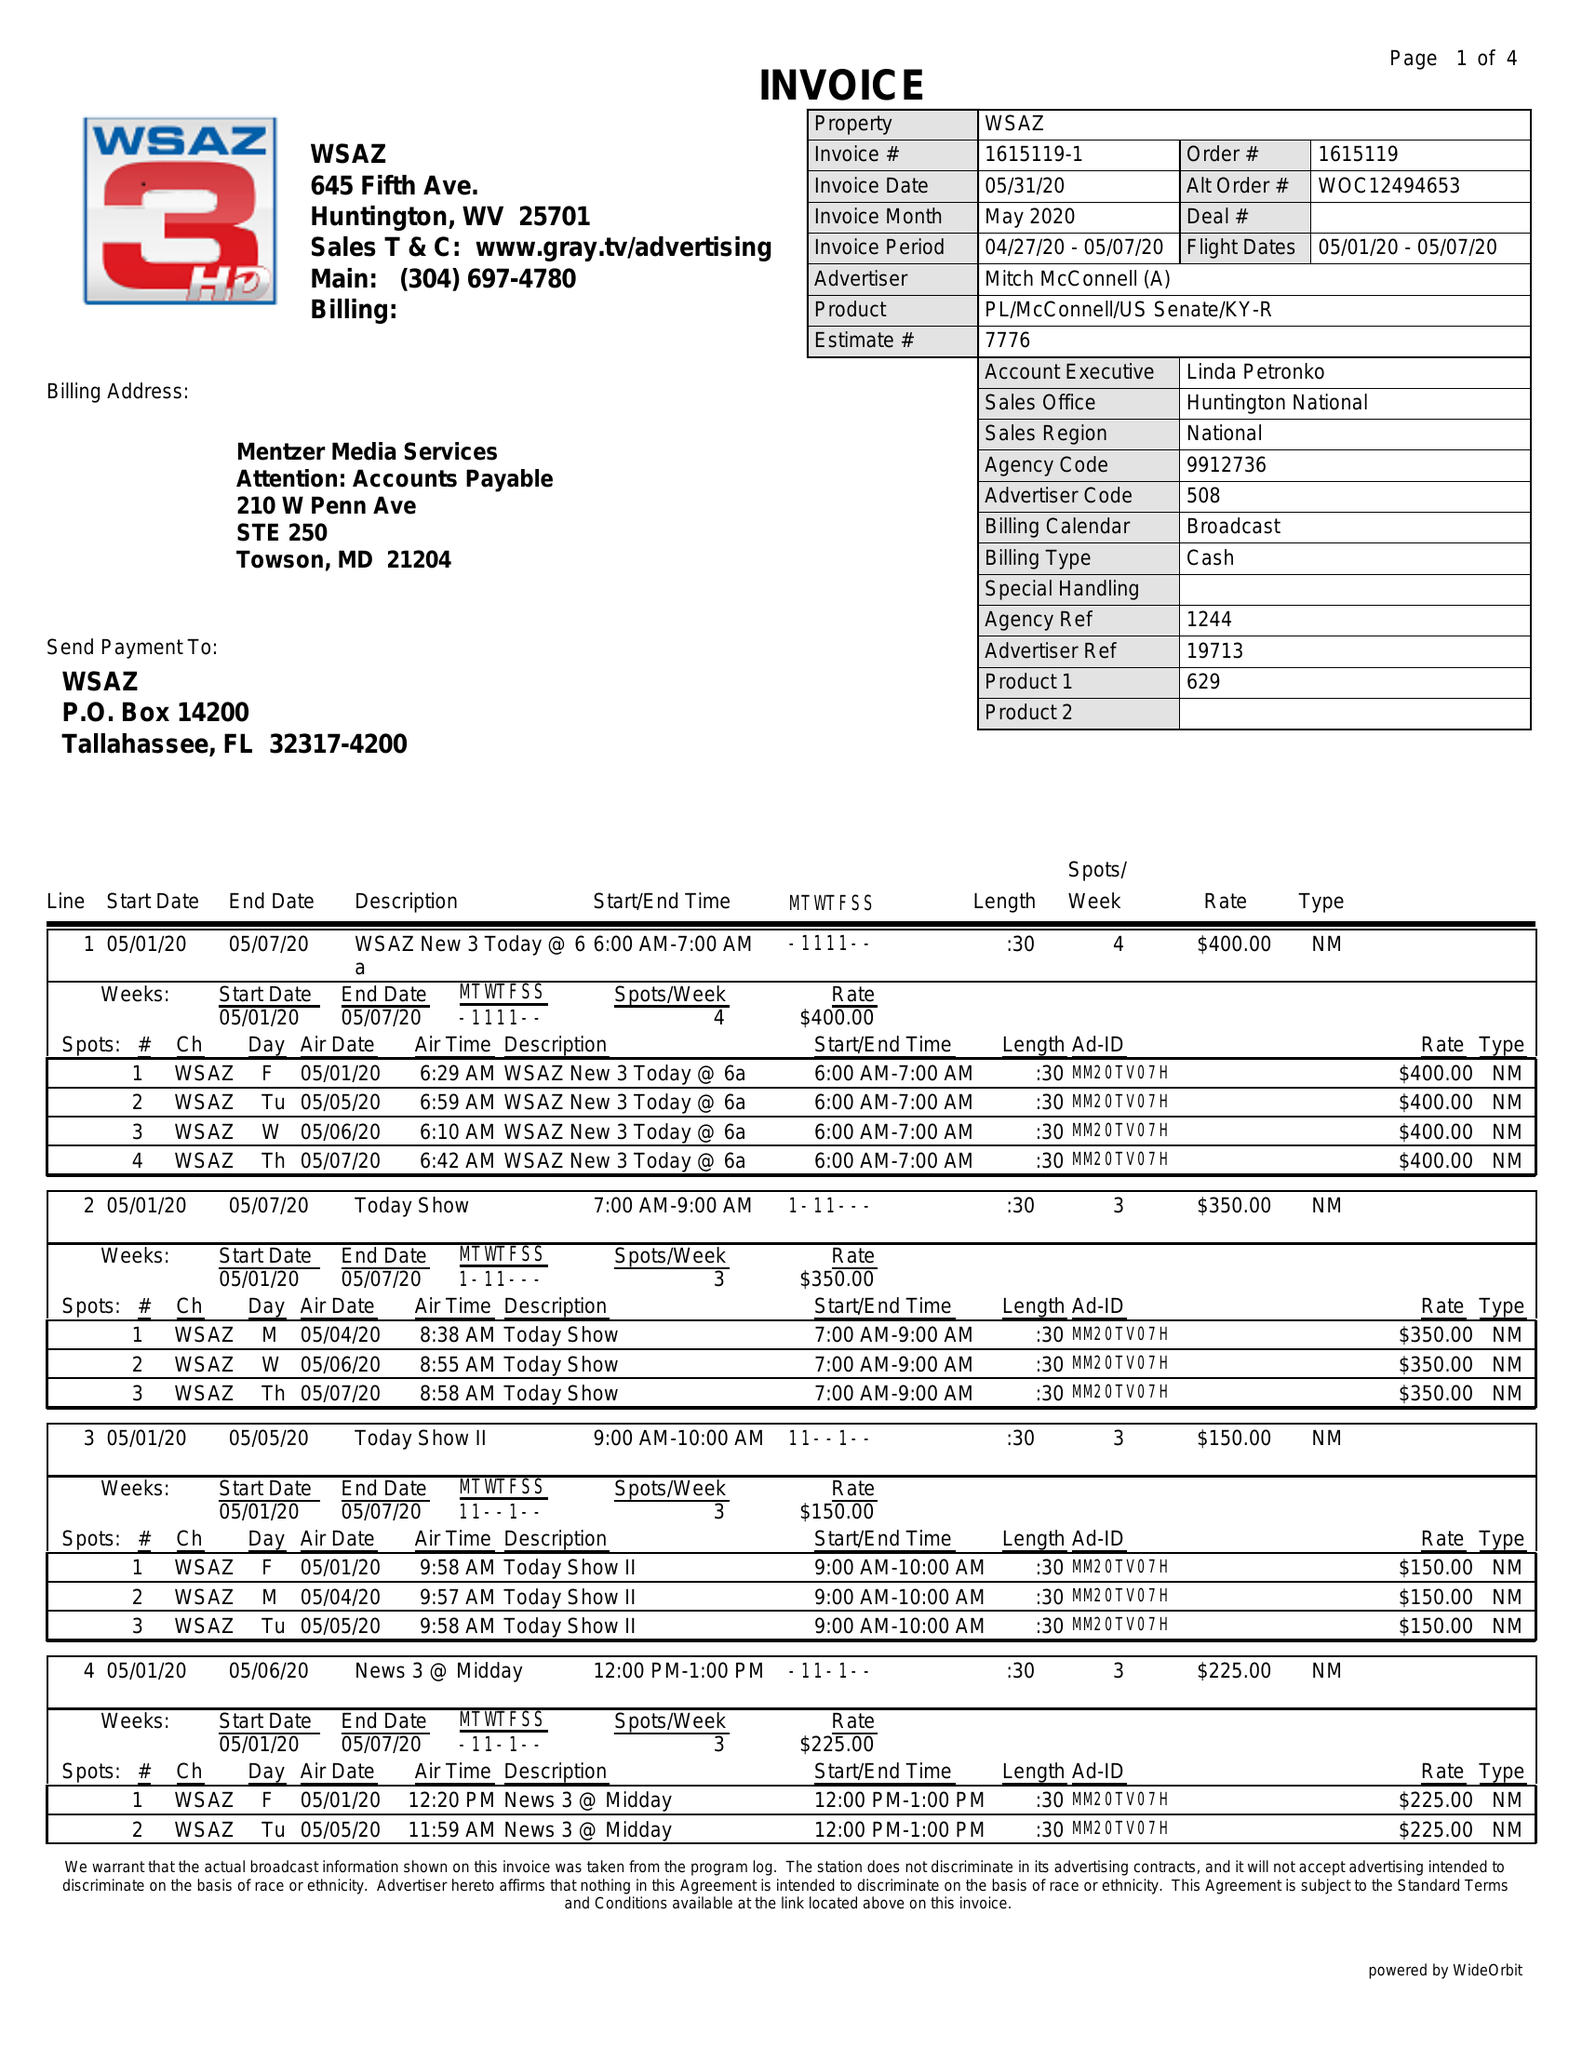What is the value for the gross_amount?
Answer the question using a single word or phrase. 14725.00 